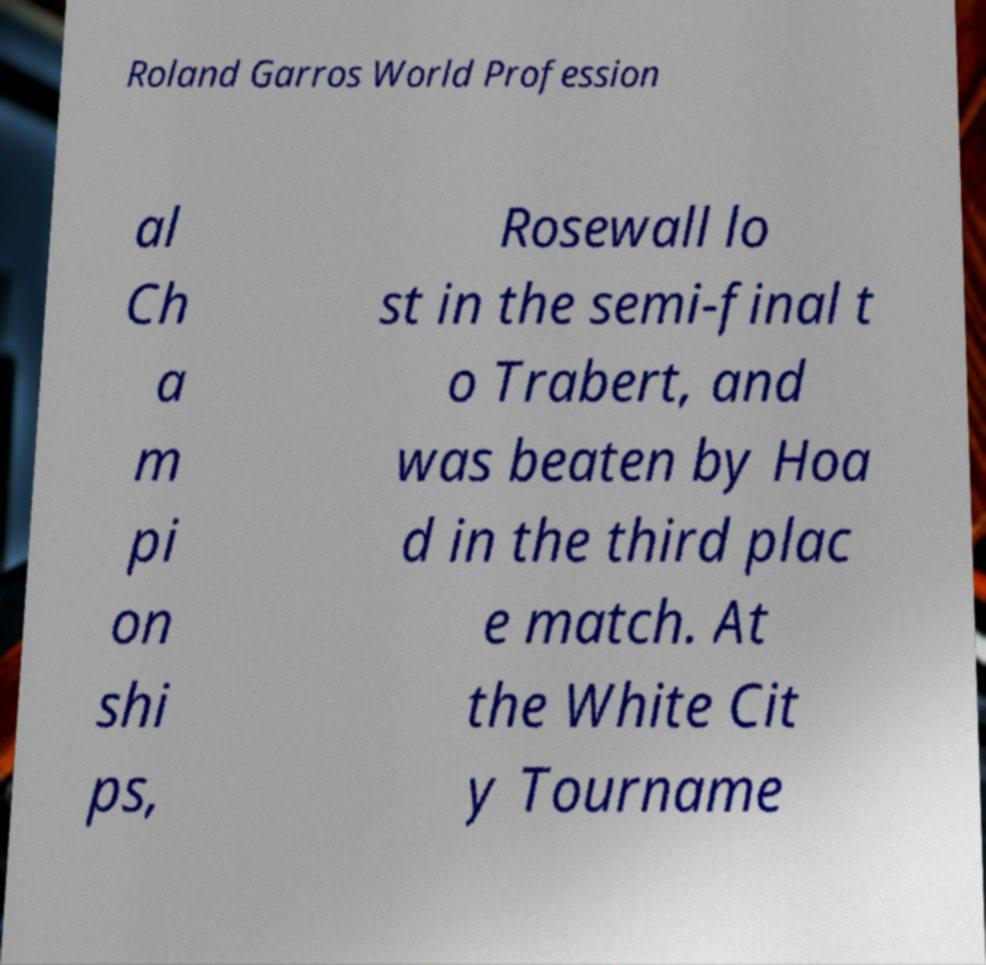Please identify and transcribe the text found in this image. Roland Garros World Profession al Ch a m pi on shi ps, Rosewall lo st in the semi-final t o Trabert, and was beaten by Hoa d in the third plac e match. At the White Cit y Tourname 